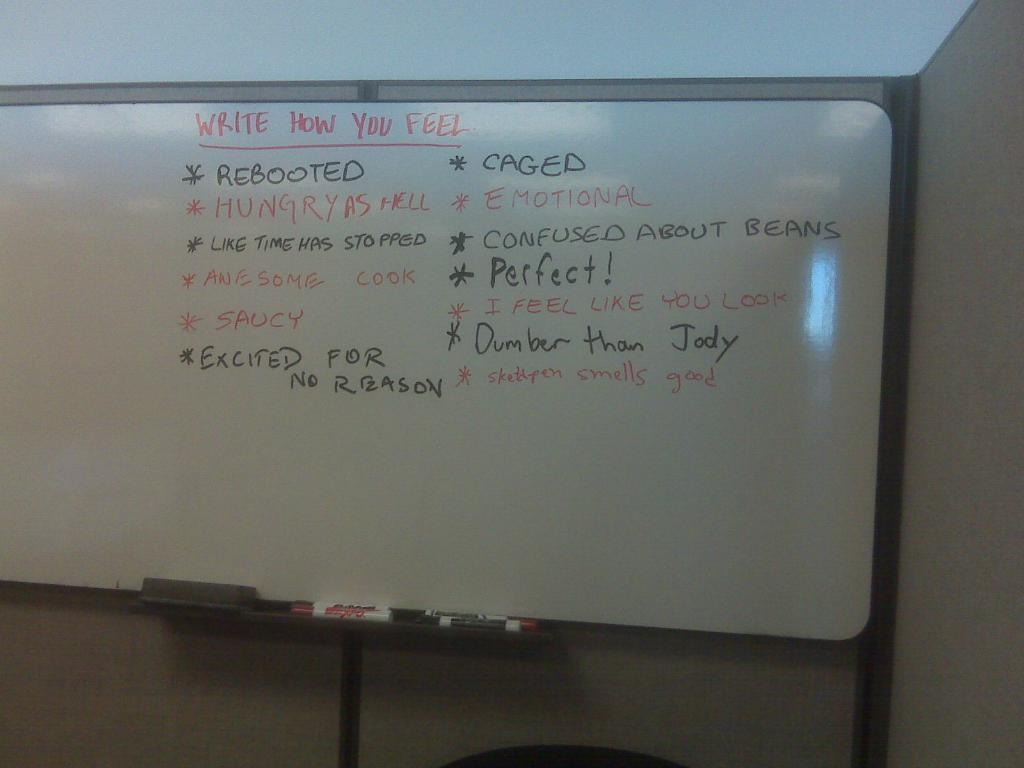<image>
Provide a brief description of the given image. A white board where people can write how they feel 